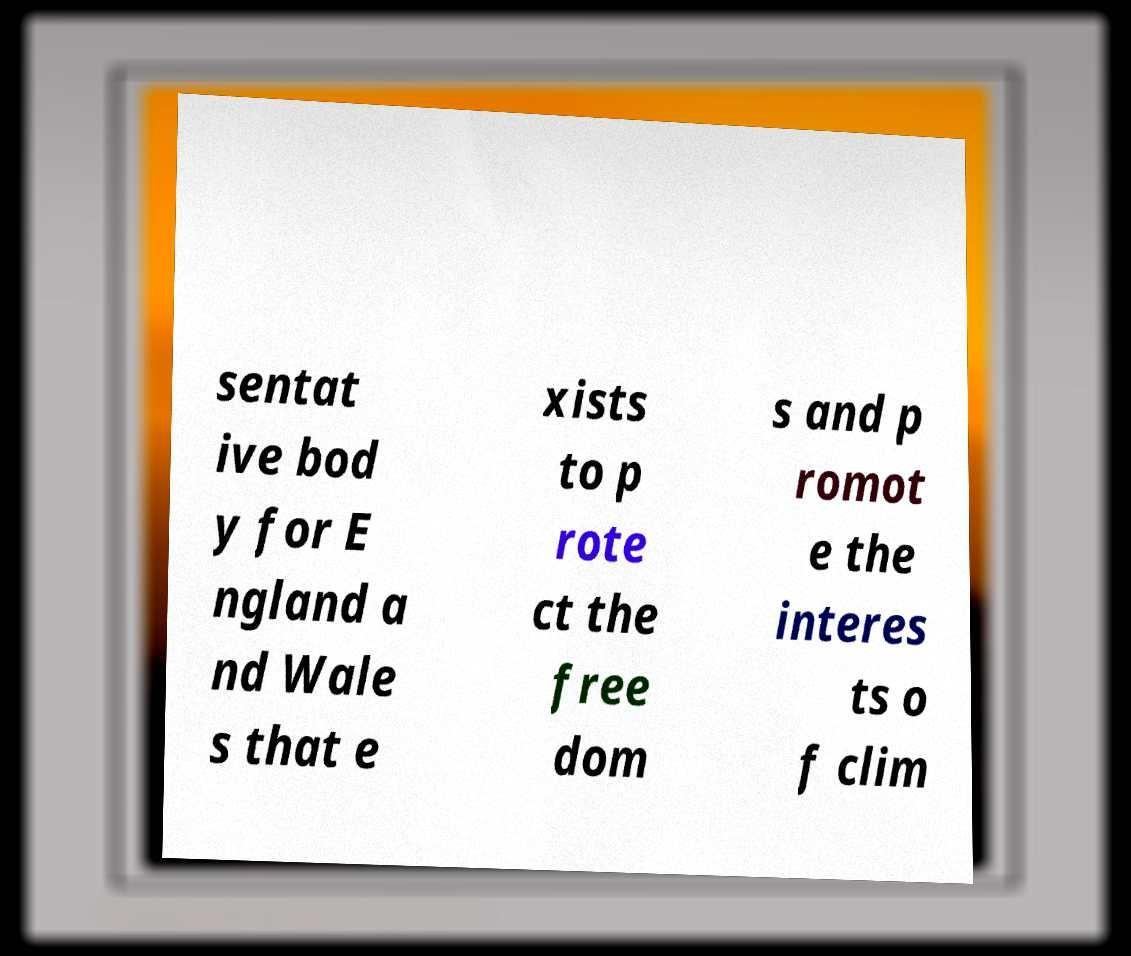Can you accurately transcribe the text from the provided image for me? sentat ive bod y for E ngland a nd Wale s that e xists to p rote ct the free dom s and p romot e the interes ts o f clim 